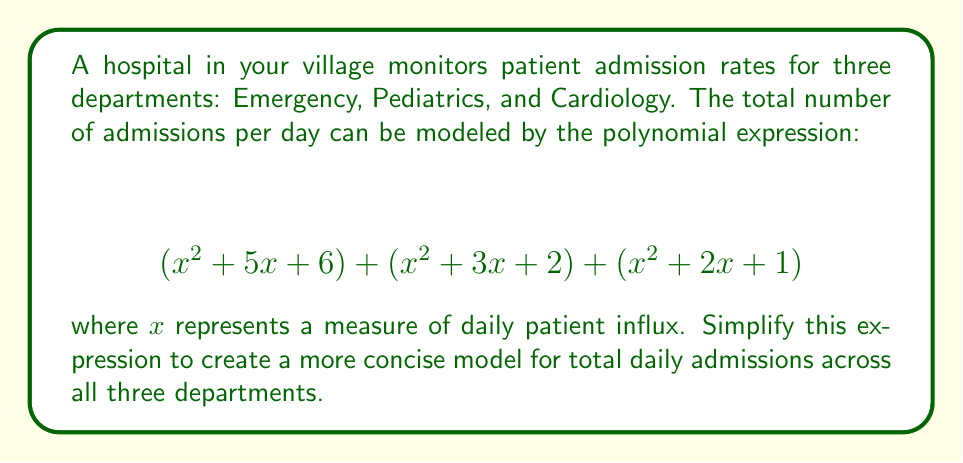Show me your answer to this math problem. To simplify this expression, we need to combine like terms:

1. Combine the $x^2$ terms:
   $$(x^2 + x^2 + x^2) = 3x^2$$

2. Combine the $x$ terms:
   $$(5x + 3x + 2x) = 10x$$

3. Combine the constant terms:
   $$(6 + 2 + 1) = 9$$

4. Write the simplified polynomial:
   $$3x^2 + 10x + 9$$

This simplified expression represents the total daily admissions across all three departments as a function of the daily patient influx measure $x$.
Answer: $$3x^2 + 10x + 9$$ 